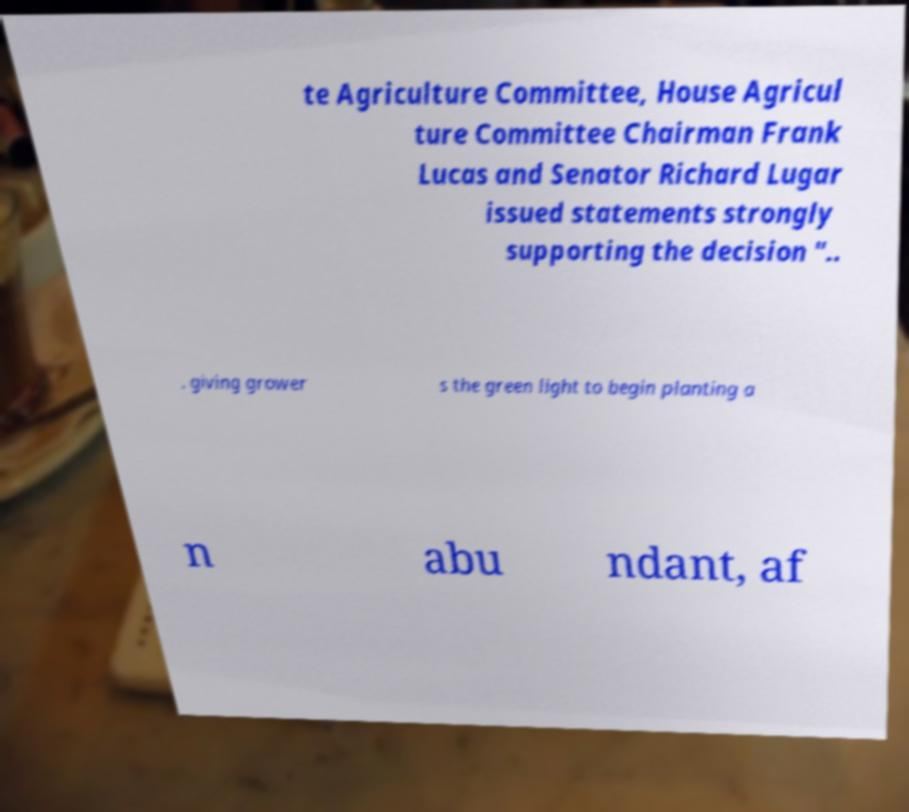Please read and relay the text visible in this image. What does it say? te Agriculture Committee, House Agricul ture Committee Chairman Frank Lucas and Senator Richard Lugar issued statements strongly supporting the decision ".. . giving grower s the green light to begin planting a n abu ndant, af 